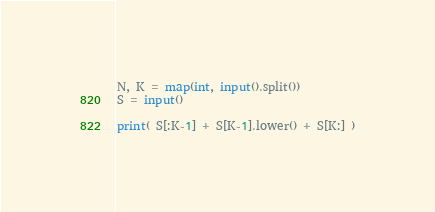<code> <loc_0><loc_0><loc_500><loc_500><_Python_>N, K = map(int, input().split())
S = input()

print( S[:K-1] + S[K-1].lower() + S[K:] )</code> 